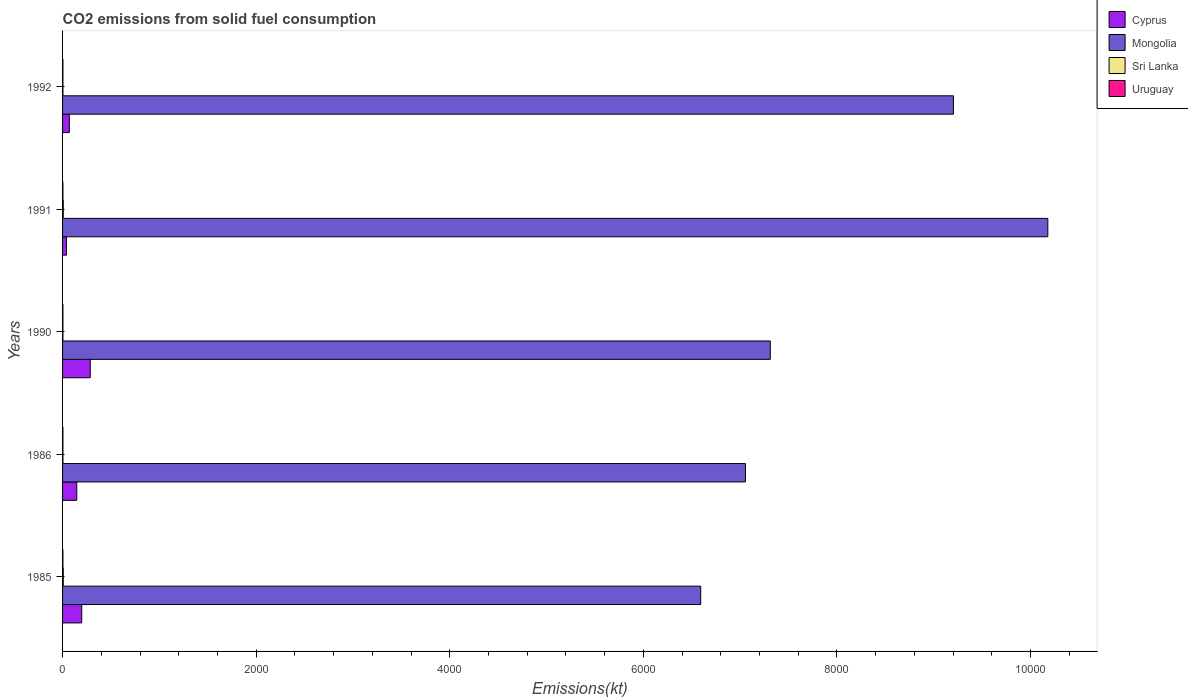How many different coloured bars are there?
Ensure brevity in your answer.  4. How many groups of bars are there?
Make the answer very short. 5. How many bars are there on the 4th tick from the top?
Offer a terse response. 4. What is the amount of CO2 emitted in Uruguay in 1986?
Offer a very short reply. 3.67. Across all years, what is the maximum amount of CO2 emitted in Mongolia?
Ensure brevity in your answer.  1.02e+04. Across all years, what is the minimum amount of CO2 emitted in Cyprus?
Your response must be concise. 40.34. What is the total amount of CO2 emitted in Mongolia in the graph?
Ensure brevity in your answer.  4.03e+04. What is the difference between the amount of CO2 emitted in Uruguay in 1990 and that in 1991?
Keep it short and to the point. 0. What is the average amount of CO2 emitted in Uruguay per year?
Provide a succinct answer. 3.67. In the year 1986, what is the difference between the amount of CO2 emitted in Uruguay and amount of CO2 emitted in Cyprus?
Provide a succinct answer. -143.01. Is the amount of CO2 emitted in Uruguay in 1985 less than that in 1986?
Your response must be concise. No. What is the difference between the highest and the second highest amount of CO2 emitted in Cyprus?
Give a very brief answer. 88.01. What is the difference between the highest and the lowest amount of CO2 emitted in Sri Lanka?
Provide a succinct answer. 3.67. Is the sum of the amount of CO2 emitted in Cyprus in 1985 and 1992 greater than the maximum amount of CO2 emitted in Uruguay across all years?
Your response must be concise. Yes. What does the 3rd bar from the top in 1990 represents?
Your answer should be very brief. Mongolia. What does the 3rd bar from the bottom in 1985 represents?
Keep it short and to the point. Sri Lanka. How many bars are there?
Your answer should be very brief. 20. How many years are there in the graph?
Your answer should be very brief. 5. Where does the legend appear in the graph?
Provide a short and direct response. Top right. How many legend labels are there?
Make the answer very short. 4. What is the title of the graph?
Give a very brief answer. CO2 emissions from solid fuel consumption. Does "Togo" appear as one of the legend labels in the graph?
Ensure brevity in your answer.  No. What is the label or title of the X-axis?
Provide a short and direct response. Emissions(kt). What is the Emissions(kt) of Cyprus in 1985?
Offer a terse response. 198.02. What is the Emissions(kt) of Mongolia in 1985?
Your answer should be very brief. 6593.27. What is the Emissions(kt) in Sri Lanka in 1985?
Provide a short and direct response. 7.33. What is the Emissions(kt) of Uruguay in 1985?
Your answer should be compact. 3.67. What is the Emissions(kt) of Cyprus in 1986?
Your response must be concise. 146.68. What is the Emissions(kt) of Mongolia in 1986?
Give a very brief answer. 7055.31. What is the Emissions(kt) of Sri Lanka in 1986?
Provide a short and direct response. 3.67. What is the Emissions(kt) in Uruguay in 1986?
Provide a short and direct response. 3.67. What is the Emissions(kt) in Cyprus in 1990?
Your response must be concise. 286.03. What is the Emissions(kt) of Mongolia in 1990?
Keep it short and to the point. 7312. What is the Emissions(kt) of Sri Lanka in 1990?
Offer a very short reply. 3.67. What is the Emissions(kt) of Uruguay in 1990?
Give a very brief answer. 3.67. What is the Emissions(kt) of Cyprus in 1991?
Keep it short and to the point. 40.34. What is the Emissions(kt) of Mongolia in 1991?
Keep it short and to the point. 1.02e+04. What is the Emissions(kt) in Sri Lanka in 1991?
Provide a short and direct response. 7.33. What is the Emissions(kt) of Uruguay in 1991?
Provide a short and direct response. 3.67. What is the Emissions(kt) of Cyprus in 1992?
Provide a succinct answer. 69.67. What is the Emissions(kt) in Mongolia in 1992?
Give a very brief answer. 9204.17. What is the Emissions(kt) of Sri Lanka in 1992?
Your answer should be compact. 3.67. What is the Emissions(kt) in Uruguay in 1992?
Give a very brief answer. 3.67. Across all years, what is the maximum Emissions(kt) of Cyprus?
Provide a short and direct response. 286.03. Across all years, what is the maximum Emissions(kt) of Mongolia?
Make the answer very short. 1.02e+04. Across all years, what is the maximum Emissions(kt) in Sri Lanka?
Provide a succinct answer. 7.33. Across all years, what is the maximum Emissions(kt) in Uruguay?
Ensure brevity in your answer.  3.67. Across all years, what is the minimum Emissions(kt) of Cyprus?
Provide a succinct answer. 40.34. Across all years, what is the minimum Emissions(kt) in Mongolia?
Provide a succinct answer. 6593.27. Across all years, what is the minimum Emissions(kt) in Sri Lanka?
Make the answer very short. 3.67. Across all years, what is the minimum Emissions(kt) of Uruguay?
Provide a succinct answer. 3.67. What is the total Emissions(kt) in Cyprus in the graph?
Give a very brief answer. 740.73. What is the total Emissions(kt) in Mongolia in the graph?
Provide a succinct answer. 4.03e+04. What is the total Emissions(kt) in Sri Lanka in the graph?
Your answer should be compact. 25.67. What is the total Emissions(kt) in Uruguay in the graph?
Make the answer very short. 18.34. What is the difference between the Emissions(kt) in Cyprus in 1985 and that in 1986?
Provide a short and direct response. 51.34. What is the difference between the Emissions(kt) of Mongolia in 1985 and that in 1986?
Provide a short and direct response. -462.04. What is the difference between the Emissions(kt) of Sri Lanka in 1985 and that in 1986?
Ensure brevity in your answer.  3.67. What is the difference between the Emissions(kt) of Uruguay in 1985 and that in 1986?
Make the answer very short. 0. What is the difference between the Emissions(kt) of Cyprus in 1985 and that in 1990?
Your response must be concise. -88.01. What is the difference between the Emissions(kt) of Mongolia in 1985 and that in 1990?
Offer a very short reply. -718.73. What is the difference between the Emissions(kt) in Sri Lanka in 1985 and that in 1990?
Provide a succinct answer. 3.67. What is the difference between the Emissions(kt) of Uruguay in 1985 and that in 1990?
Provide a short and direct response. 0. What is the difference between the Emissions(kt) in Cyprus in 1985 and that in 1991?
Your answer should be very brief. 157.68. What is the difference between the Emissions(kt) in Mongolia in 1985 and that in 1991?
Offer a very short reply. -3586.33. What is the difference between the Emissions(kt) of Sri Lanka in 1985 and that in 1991?
Your answer should be compact. 0. What is the difference between the Emissions(kt) of Cyprus in 1985 and that in 1992?
Give a very brief answer. 128.34. What is the difference between the Emissions(kt) in Mongolia in 1985 and that in 1992?
Give a very brief answer. -2610.9. What is the difference between the Emissions(kt) in Sri Lanka in 1985 and that in 1992?
Your answer should be very brief. 3.67. What is the difference between the Emissions(kt) in Uruguay in 1985 and that in 1992?
Your answer should be compact. 0. What is the difference between the Emissions(kt) of Cyprus in 1986 and that in 1990?
Your response must be concise. -139.35. What is the difference between the Emissions(kt) in Mongolia in 1986 and that in 1990?
Make the answer very short. -256.69. What is the difference between the Emissions(kt) of Sri Lanka in 1986 and that in 1990?
Your response must be concise. 0. What is the difference between the Emissions(kt) of Uruguay in 1986 and that in 1990?
Ensure brevity in your answer.  0. What is the difference between the Emissions(kt) of Cyprus in 1986 and that in 1991?
Ensure brevity in your answer.  106.34. What is the difference between the Emissions(kt) of Mongolia in 1986 and that in 1991?
Offer a very short reply. -3124.28. What is the difference between the Emissions(kt) in Sri Lanka in 1986 and that in 1991?
Provide a succinct answer. -3.67. What is the difference between the Emissions(kt) in Uruguay in 1986 and that in 1991?
Your answer should be very brief. 0. What is the difference between the Emissions(kt) in Cyprus in 1986 and that in 1992?
Ensure brevity in your answer.  77.01. What is the difference between the Emissions(kt) in Mongolia in 1986 and that in 1992?
Offer a very short reply. -2148.86. What is the difference between the Emissions(kt) of Sri Lanka in 1986 and that in 1992?
Give a very brief answer. 0. What is the difference between the Emissions(kt) of Cyprus in 1990 and that in 1991?
Your answer should be compact. 245.69. What is the difference between the Emissions(kt) in Mongolia in 1990 and that in 1991?
Provide a short and direct response. -2867.59. What is the difference between the Emissions(kt) of Sri Lanka in 1990 and that in 1991?
Your answer should be compact. -3.67. What is the difference between the Emissions(kt) of Cyprus in 1990 and that in 1992?
Your answer should be very brief. 216.35. What is the difference between the Emissions(kt) of Mongolia in 1990 and that in 1992?
Give a very brief answer. -1892.17. What is the difference between the Emissions(kt) in Uruguay in 1990 and that in 1992?
Your answer should be compact. 0. What is the difference between the Emissions(kt) in Cyprus in 1991 and that in 1992?
Offer a very short reply. -29.34. What is the difference between the Emissions(kt) in Mongolia in 1991 and that in 1992?
Offer a very short reply. 975.42. What is the difference between the Emissions(kt) in Sri Lanka in 1991 and that in 1992?
Provide a succinct answer. 3.67. What is the difference between the Emissions(kt) of Cyprus in 1985 and the Emissions(kt) of Mongolia in 1986?
Offer a very short reply. -6857.29. What is the difference between the Emissions(kt) of Cyprus in 1985 and the Emissions(kt) of Sri Lanka in 1986?
Ensure brevity in your answer.  194.35. What is the difference between the Emissions(kt) of Cyprus in 1985 and the Emissions(kt) of Uruguay in 1986?
Your answer should be very brief. 194.35. What is the difference between the Emissions(kt) of Mongolia in 1985 and the Emissions(kt) of Sri Lanka in 1986?
Ensure brevity in your answer.  6589.6. What is the difference between the Emissions(kt) of Mongolia in 1985 and the Emissions(kt) of Uruguay in 1986?
Your response must be concise. 6589.6. What is the difference between the Emissions(kt) of Sri Lanka in 1985 and the Emissions(kt) of Uruguay in 1986?
Give a very brief answer. 3.67. What is the difference between the Emissions(kt) of Cyprus in 1985 and the Emissions(kt) of Mongolia in 1990?
Your answer should be very brief. -7113.98. What is the difference between the Emissions(kt) in Cyprus in 1985 and the Emissions(kt) in Sri Lanka in 1990?
Offer a terse response. 194.35. What is the difference between the Emissions(kt) in Cyprus in 1985 and the Emissions(kt) in Uruguay in 1990?
Your answer should be very brief. 194.35. What is the difference between the Emissions(kt) in Mongolia in 1985 and the Emissions(kt) in Sri Lanka in 1990?
Your answer should be compact. 6589.6. What is the difference between the Emissions(kt) in Mongolia in 1985 and the Emissions(kt) in Uruguay in 1990?
Your response must be concise. 6589.6. What is the difference between the Emissions(kt) of Sri Lanka in 1985 and the Emissions(kt) of Uruguay in 1990?
Offer a very short reply. 3.67. What is the difference between the Emissions(kt) of Cyprus in 1985 and the Emissions(kt) of Mongolia in 1991?
Give a very brief answer. -9981.57. What is the difference between the Emissions(kt) in Cyprus in 1985 and the Emissions(kt) in Sri Lanka in 1991?
Ensure brevity in your answer.  190.68. What is the difference between the Emissions(kt) of Cyprus in 1985 and the Emissions(kt) of Uruguay in 1991?
Ensure brevity in your answer.  194.35. What is the difference between the Emissions(kt) of Mongolia in 1985 and the Emissions(kt) of Sri Lanka in 1991?
Offer a very short reply. 6585.93. What is the difference between the Emissions(kt) in Mongolia in 1985 and the Emissions(kt) in Uruguay in 1991?
Keep it short and to the point. 6589.6. What is the difference between the Emissions(kt) of Sri Lanka in 1985 and the Emissions(kt) of Uruguay in 1991?
Provide a short and direct response. 3.67. What is the difference between the Emissions(kt) in Cyprus in 1985 and the Emissions(kt) in Mongolia in 1992?
Your answer should be very brief. -9006.15. What is the difference between the Emissions(kt) of Cyprus in 1985 and the Emissions(kt) of Sri Lanka in 1992?
Give a very brief answer. 194.35. What is the difference between the Emissions(kt) of Cyprus in 1985 and the Emissions(kt) of Uruguay in 1992?
Your answer should be very brief. 194.35. What is the difference between the Emissions(kt) in Mongolia in 1985 and the Emissions(kt) in Sri Lanka in 1992?
Give a very brief answer. 6589.6. What is the difference between the Emissions(kt) of Mongolia in 1985 and the Emissions(kt) of Uruguay in 1992?
Provide a succinct answer. 6589.6. What is the difference between the Emissions(kt) of Sri Lanka in 1985 and the Emissions(kt) of Uruguay in 1992?
Your answer should be very brief. 3.67. What is the difference between the Emissions(kt) in Cyprus in 1986 and the Emissions(kt) in Mongolia in 1990?
Your response must be concise. -7165.32. What is the difference between the Emissions(kt) of Cyprus in 1986 and the Emissions(kt) of Sri Lanka in 1990?
Give a very brief answer. 143.01. What is the difference between the Emissions(kt) of Cyprus in 1986 and the Emissions(kt) of Uruguay in 1990?
Offer a terse response. 143.01. What is the difference between the Emissions(kt) in Mongolia in 1986 and the Emissions(kt) in Sri Lanka in 1990?
Make the answer very short. 7051.64. What is the difference between the Emissions(kt) in Mongolia in 1986 and the Emissions(kt) in Uruguay in 1990?
Provide a succinct answer. 7051.64. What is the difference between the Emissions(kt) in Sri Lanka in 1986 and the Emissions(kt) in Uruguay in 1990?
Provide a succinct answer. 0. What is the difference between the Emissions(kt) in Cyprus in 1986 and the Emissions(kt) in Mongolia in 1991?
Offer a terse response. -1.00e+04. What is the difference between the Emissions(kt) of Cyprus in 1986 and the Emissions(kt) of Sri Lanka in 1991?
Your answer should be compact. 139.35. What is the difference between the Emissions(kt) of Cyprus in 1986 and the Emissions(kt) of Uruguay in 1991?
Offer a very short reply. 143.01. What is the difference between the Emissions(kt) of Mongolia in 1986 and the Emissions(kt) of Sri Lanka in 1991?
Offer a terse response. 7047.97. What is the difference between the Emissions(kt) of Mongolia in 1986 and the Emissions(kt) of Uruguay in 1991?
Your answer should be compact. 7051.64. What is the difference between the Emissions(kt) in Cyprus in 1986 and the Emissions(kt) in Mongolia in 1992?
Your answer should be compact. -9057.49. What is the difference between the Emissions(kt) of Cyprus in 1986 and the Emissions(kt) of Sri Lanka in 1992?
Ensure brevity in your answer.  143.01. What is the difference between the Emissions(kt) in Cyprus in 1986 and the Emissions(kt) in Uruguay in 1992?
Make the answer very short. 143.01. What is the difference between the Emissions(kt) of Mongolia in 1986 and the Emissions(kt) of Sri Lanka in 1992?
Offer a terse response. 7051.64. What is the difference between the Emissions(kt) in Mongolia in 1986 and the Emissions(kt) in Uruguay in 1992?
Offer a terse response. 7051.64. What is the difference between the Emissions(kt) in Cyprus in 1990 and the Emissions(kt) in Mongolia in 1991?
Your response must be concise. -9893.57. What is the difference between the Emissions(kt) in Cyprus in 1990 and the Emissions(kt) in Sri Lanka in 1991?
Give a very brief answer. 278.69. What is the difference between the Emissions(kt) of Cyprus in 1990 and the Emissions(kt) of Uruguay in 1991?
Provide a succinct answer. 282.36. What is the difference between the Emissions(kt) of Mongolia in 1990 and the Emissions(kt) of Sri Lanka in 1991?
Your answer should be very brief. 7304.66. What is the difference between the Emissions(kt) in Mongolia in 1990 and the Emissions(kt) in Uruguay in 1991?
Offer a very short reply. 7308.33. What is the difference between the Emissions(kt) of Cyprus in 1990 and the Emissions(kt) of Mongolia in 1992?
Your response must be concise. -8918.14. What is the difference between the Emissions(kt) in Cyprus in 1990 and the Emissions(kt) in Sri Lanka in 1992?
Provide a short and direct response. 282.36. What is the difference between the Emissions(kt) of Cyprus in 1990 and the Emissions(kt) of Uruguay in 1992?
Your response must be concise. 282.36. What is the difference between the Emissions(kt) of Mongolia in 1990 and the Emissions(kt) of Sri Lanka in 1992?
Your response must be concise. 7308.33. What is the difference between the Emissions(kt) of Mongolia in 1990 and the Emissions(kt) of Uruguay in 1992?
Keep it short and to the point. 7308.33. What is the difference between the Emissions(kt) in Sri Lanka in 1990 and the Emissions(kt) in Uruguay in 1992?
Offer a terse response. 0. What is the difference between the Emissions(kt) in Cyprus in 1991 and the Emissions(kt) in Mongolia in 1992?
Provide a succinct answer. -9163.83. What is the difference between the Emissions(kt) in Cyprus in 1991 and the Emissions(kt) in Sri Lanka in 1992?
Offer a terse response. 36.67. What is the difference between the Emissions(kt) in Cyprus in 1991 and the Emissions(kt) in Uruguay in 1992?
Your response must be concise. 36.67. What is the difference between the Emissions(kt) of Mongolia in 1991 and the Emissions(kt) of Sri Lanka in 1992?
Ensure brevity in your answer.  1.02e+04. What is the difference between the Emissions(kt) in Mongolia in 1991 and the Emissions(kt) in Uruguay in 1992?
Provide a short and direct response. 1.02e+04. What is the difference between the Emissions(kt) of Sri Lanka in 1991 and the Emissions(kt) of Uruguay in 1992?
Offer a very short reply. 3.67. What is the average Emissions(kt) in Cyprus per year?
Ensure brevity in your answer.  148.15. What is the average Emissions(kt) of Mongolia per year?
Ensure brevity in your answer.  8068.87. What is the average Emissions(kt) in Sri Lanka per year?
Your answer should be very brief. 5.13. What is the average Emissions(kt) of Uruguay per year?
Your answer should be compact. 3.67. In the year 1985, what is the difference between the Emissions(kt) of Cyprus and Emissions(kt) of Mongolia?
Ensure brevity in your answer.  -6395.25. In the year 1985, what is the difference between the Emissions(kt) in Cyprus and Emissions(kt) in Sri Lanka?
Make the answer very short. 190.68. In the year 1985, what is the difference between the Emissions(kt) in Cyprus and Emissions(kt) in Uruguay?
Keep it short and to the point. 194.35. In the year 1985, what is the difference between the Emissions(kt) in Mongolia and Emissions(kt) in Sri Lanka?
Keep it short and to the point. 6585.93. In the year 1985, what is the difference between the Emissions(kt) in Mongolia and Emissions(kt) in Uruguay?
Keep it short and to the point. 6589.6. In the year 1985, what is the difference between the Emissions(kt) of Sri Lanka and Emissions(kt) of Uruguay?
Provide a succinct answer. 3.67. In the year 1986, what is the difference between the Emissions(kt) in Cyprus and Emissions(kt) in Mongolia?
Make the answer very short. -6908.63. In the year 1986, what is the difference between the Emissions(kt) of Cyprus and Emissions(kt) of Sri Lanka?
Your answer should be compact. 143.01. In the year 1986, what is the difference between the Emissions(kt) of Cyprus and Emissions(kt) of Uruguay?
Your answer should be compact. 143.01. In the year 1986, what is the difference between the Emissions(kt) of Mongolia and Emissions(kt) of Sri Lanka?
Make the answer very short. 7051.64. In the year 1986, what is the difference between the Emissions(kt) of Mongolia and Emissions(kt) of Uruguay?
Offer a very short reply. 7051.64. In the year 1990, what is the difference between the Emissions(kt) in Cyprus and Emissions(kt) in Mongolia?
Make the answer very short. -7025.97. In the year 1990, what is the difference between the Emissions(kt) in Cyprus and Emissions(kt) in Sri Lanka?
Ensure brevity in your answer.  282.36. In the year 1990, what is the difference between the Emissions(kt) in Cyprus and Emissions(kt) in Uruguay?
Your response must be concise. 282.36. In the year 1990, what is the difference between the Emissions(kt) of Mongolia and Emissions(kt) of Sri Lanka?
Keep it short and to the point. 7308.33. In the year 1990, what is the difference between the Emissions(kt) of Mongolia and Emissions(kt) of Uruguay?
Offer a terse response. 7308.33. In the year 1990, what is the difference between the Emissions(kt) in Sri Lanka and Emissions(kt) in Uruguay?
Provide a short and direct response. 0. In the year 1991, what is the difference between the Emissions(kt) of Cyprus and Emissions(kt) of Mongolia?
Offer a terse response. -1.01e+04. In the year 1991, what is the difference between the Emissions(kt) of Cyprus and Emissions(kt) of Sri Lanka?
Give a very brief answer. 33. In the year 1991, what is the difference between the Emissions(kt) in Cyprus and Emissions(kt) in Uruguay?
Your answer should be very brief. 36.67. In the year 1991, what is the difference between the Emissions(kt) of Mongolia and Emissions(kt) of Sri Lanka?
Your answer should be very brief. 1.02e+04. In the year 1991, what is the difference between the Emissions(kt) in Mongolia and Emissions(kt) in Uruguay?
Your response must be concise. 1.02e+04. In the year 1991, what is the difference between the Emissions(kt) of Sri Lanka and Emissions(kt) of Uruguay?
Provide a short and direct response. 3.67. In the year 1992, what is the difference between the Emissions(kt) in Cyprus and Emissions(kt) in Mongolia?
Your answer should be very brief. -9134.5. In the year 1992, what is the difference between the Emissions(kt) of Cyprus and Emissions(kt) of Sri Lanka?
Keep it short and to the point. 66.01. In the year 1992, what is the difference between the Emissions(kt) of Cyprus and Emissions(kt) of Uruguay?
Your response must be concise. 66.01. In the year 1992, what is the difference between the Emissions(kt) of Mongolia and Emissions(kt) of Sri Lanka?
Ensure brevity in your answer.  9200.5. In the year 1992, what is the difference between the Emissions(kt) of Mongolia and Emissions(kt) of Uruguay?
Give a very brief answer. 9200.5. In the year 1992, what is the difference between the Emissions(kt) of Sri Lanka and Emissions(kt) of Uruguay?
Ensure brevity in your answer.  0. What is the ratio of the Emissions(kt) of Cyprus in 1985 to that in 1986?
Give a very brief answer. 1.35. What is the ratio of the Emissions(kt) of Mongolia in 1985 to that in 1986?
Your answer should be very brief. 0.93. What is the ratio of the Emissions(kt) in Uruguay in 1985 to that in 1986?
Your response must be concise. 1. What is the ratio of the Emissions(kt) of Cyprus in 1985 to that in 1990?
Keep it short and to the point. 0.69. What is the ratio of the Emissions(kt) in Mongolia in 1985 to that in 1990?
Make the answer very short. 0.9. What is the ratio of the Emissions(kt) in Cyprus in 1985 to that in 1991?
Your response must be concise. 4.91. What is the ratio of the Emissions(kt) of Mongolia in 1985 to that in 1991?
Keep it short and to the point. 0.65. What is the ratio of the Emissions(kt) of Sri Lanka in 1985 to that in 1991?
Your answer should be compact. 1. What is the ratio of the Emissions(kt) in Cyprus in 1985 to that in 1992?
Your answer should be compact. 2.84. What is the ratio of the Emissions(kt) of Mongolia in 1985 to that in 1992?
Make the answer very short. 0.72. What is the ratio of the Emissions(kt) of Sri Lanka in 1985 to that in 1992?
Give a very brief answer. 2. What is the ratio of the Emissions(kt) of Uruguay in 1985 to that in 1992?
Make the answer very short. 1. What is the ratio of the Emissions(kt) in Cyprus in 1986 to that in 1990?
Your response must be concise. 0.51. What is the ratio of the Emissions(kt) of Mongolia in 1986 to that in 1990?
Provide a short and direct response. 0.96. What is the ratio of the Emissions(kt) in Sri Lanka in 1986 to that in 1990?
Offer a very short reply. 1. What is the ratio of the Emissions(kt) of Uruguay in 1986 to that in 1990?
Offer a terse response. 1. What is the ratio of the Emissions(kt) in Cyprus in 1986 to that in 1991?
Provide a succinct answer. 3.64. What is the ratio of the Emissions(kt) of Mongolia in 1986 to that in 1991?
Offer a very short reply. 0.69. What is the ratio of the Emissions(kt) in Uruguay in 1986 to that in 1991?
Your answer should be very brief. 1. What is the ratio of the Emissions(kt) in Cyprus in 1986 to that in 1992?
Keep it short and to the point. 2.11. What is the ratio of the Emissions(kt) in Mongolia in 1986 to that in 1992?
Ensure brevity in your answer.  0.77. What is the ratio of the Emissions(kt) of Sri Lanka in 1986 to that in 1992?
Make the answer very short. 1. What is the ratio of the Emissions(kt) in Uruguay in 1986 to that in 1992?
Make the answer very short. 1. What is the ratio of the Emissions(kt) in Cyprus in 1990 to that in 1991?
Provide a short and direct response. 7.09. What is the ratio of the Emissions(kt) in Mongolia in 1990 to that in 1991?
Provide a succinct answer. 0.72. What is the ratio of the Emissions(kt) in Sri Lanka in 1990 to that in 1991?
Your answer should be compact. 0.5. What is the ratio of the Emissions(kt) in Cyprus in 1990 to that in 1992?
Your answer should be very brief. 4.11. What is the ratio of the Emissions(kt) in Mongolia in 1990 to that in 1992?
Keep it short and to the point. 0.79. What is the ratio of the Emissions(kt) of Cyprus in 1991 to that in 1992?
Your answer should be compact. 0.58. What is the ratio of the Emissions(kt) of Mongolia in 1991 to that in 1992?
Provide a short and direct response. 1.11. What is the ratio of the Emissions(kt) in Sri Lanka in 1991 to that in 1992?
Ensure brevity in your answer.  2. What is the ratio of the Emissions(kt) of Uruguay in 1991 to that in 1992?
Ensure brevity in your answer.  1. What is the difference between the highest and the second highest Emissions(kt) of Cyprus?
Keep it short and to the point. 88.01. What is the difference between the highest and the second highest Emissions(kt) of Mongolia?
Provide a short and direct response. 975.42. What is the difference between the highest and the lowest Emissions(kt) in Cyprus?
Ensure brevity in your answer.  245.69. What is the difference between the highest and the lowest Emissions(kt) of Mongolia?
Offer a very short reply. 3586.33. What is the difference between the highest and the lowest Emissions(kt) of Sri Lanka?
Your answer should be compact. 3.67. 